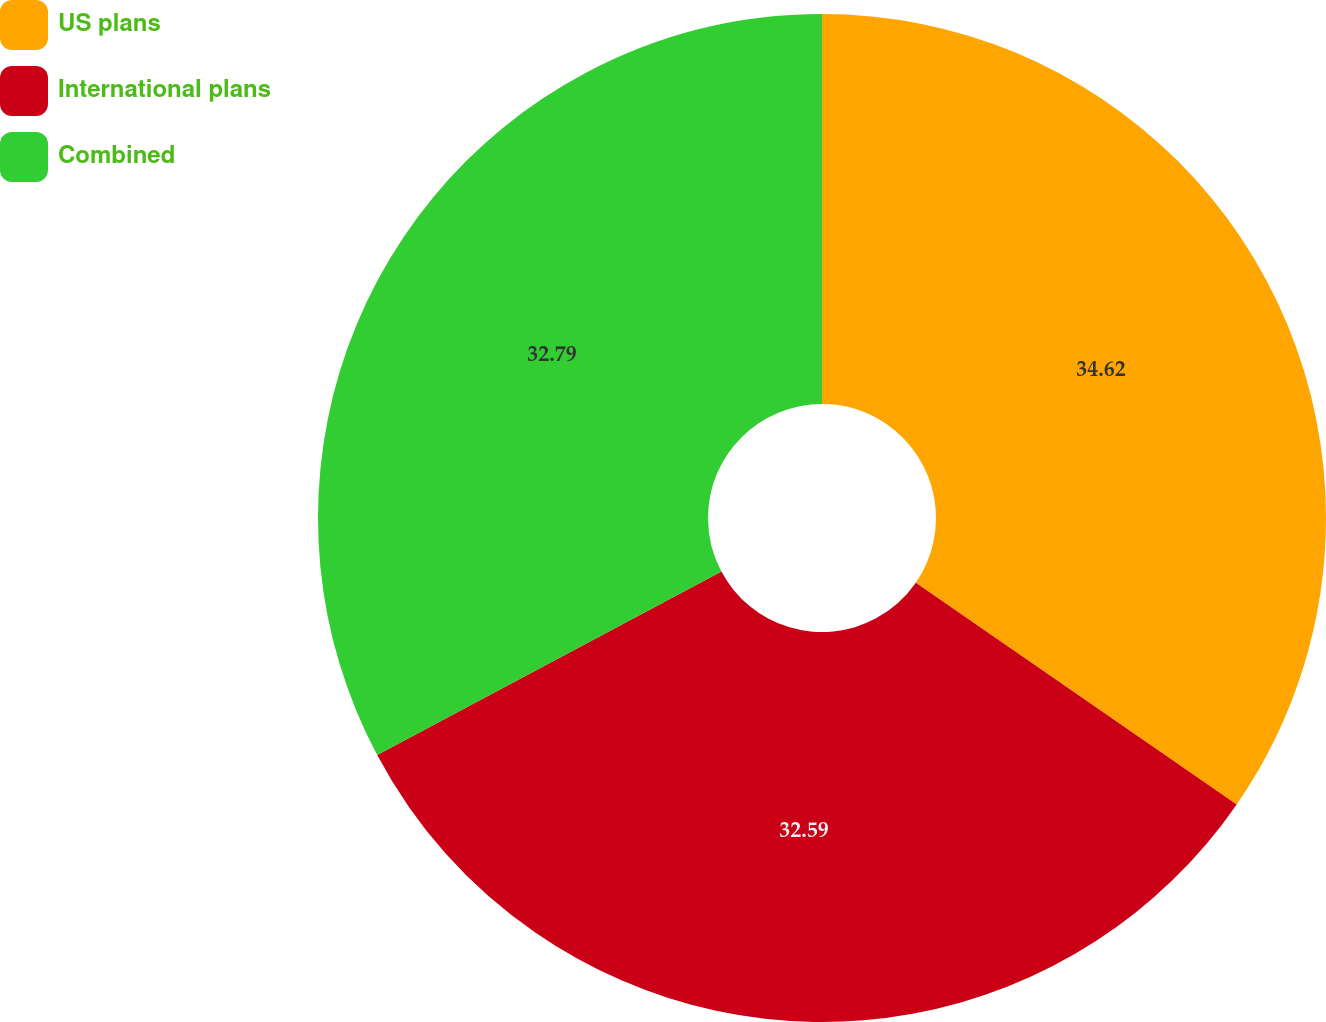Convert chart to OTSL. <chart><loc_0><loc_0><loc_500><loc_500><pie_chart><fcel>US plans<fcel>International plans<fcel>Combined<nl><fcel>34.62%<fcel>32.59%<fcel>32.79%<nl></chart> 